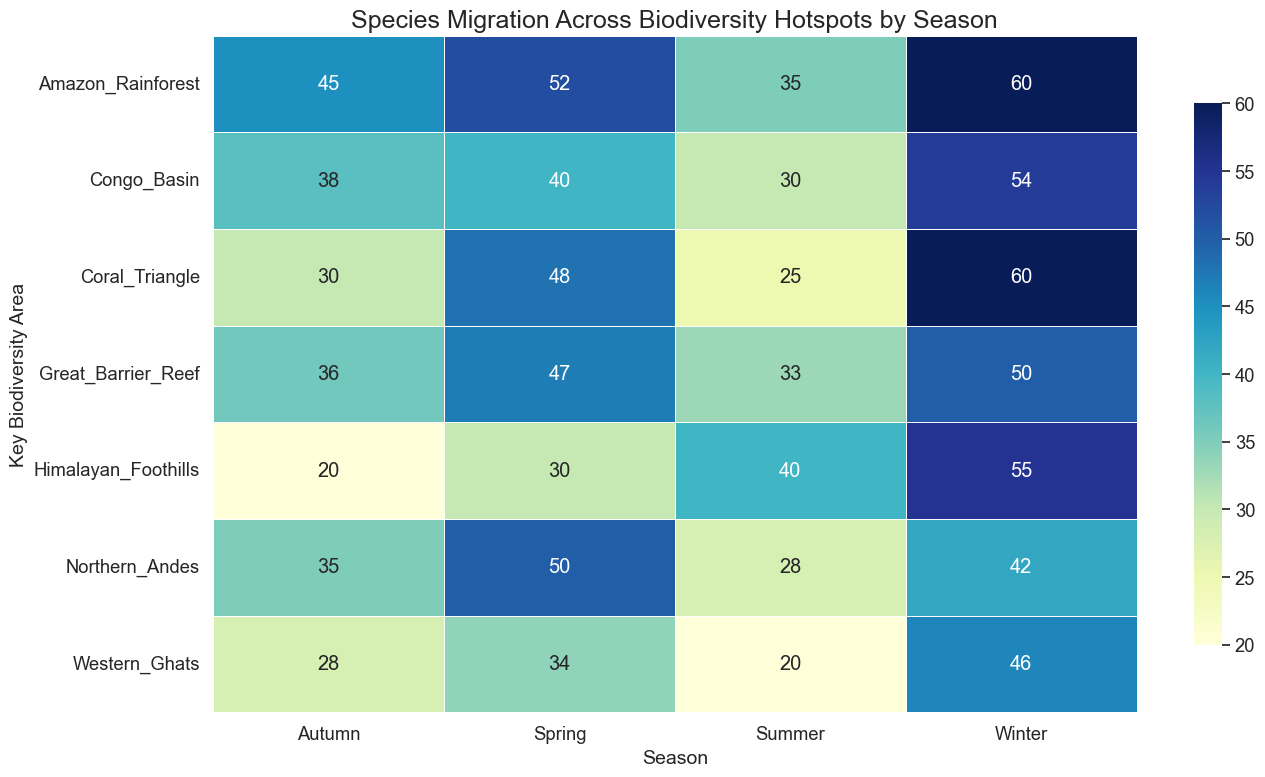What is the average number of species migrated in the Coral Triangle across all seasons? To find the average, sum up the species migrated in each season for Coral Triangle and divide by the number of seasons. The values are 48 in Spring, 25 in Summer, 30 in Autumn, and 60 in Winter. Summing these gives us 48 + 25 + 30 + 60 = 163. There are 4 seasons, so the average is 163 / 4 = 40.75.
Answer: 40.75 Which biodiversity area experiences the highest species migration during winter? To answer this, look at the row labeled "Winter" and find the highest numerical value. Winter values are Amazon Rainforest (60), Congo Basin (54), Coral Triangle (60), Himalayan Foothills (55), Great Barrier Reef (50), Northern Andes (42), and Western Ghats (46). The highest values are in Amazon Rainforest and Coral Triangle, both with 60.
Answer: Amazon Rainforest and Coral Triangle In which season does the Western Ghats have the lowest species migration, and what is that value? Examine the values for the Western Ghats across all seasons. Spring (34), Summer (20), Autumn (28), Winter (46). The lowest value is in Summer with a count of 20.
Answer: Summer, 20 How does species migration in Spring compare between the Amazon Rainforest and the Great Barrier Reef? Look at the species migration values for Spring in both the Amazon Rainforest (52) and the Great Barrier Reef (47). To compare, 52 (Amazon Rainforest) is greater than 47 (Great Barrier Reef).
Answer: Amazon Rainforest has higher migration in Spring What is the difference in species migration between Spring and Autumn in the Northern Andes? Look at the values for Northern Andes in Spring (50) and Autumn (35). To find the difference, compute 50 (Spring) - 35 (Autumn), which equals 15.
Answer: 15 Which season shows the least variation in species migration across all biodiversity areas? To determine the season with the least variation, examine the visual closeness of the values across seasons. Summer values appear closer, with a lower range of variation between maximum and minimum values. Visually the numbers are more 'bunched' together.
Answer: Summer How does species migration in Winter compare between the Himalayan Foothills and Congo Basin? Check the Winter values for the Himalayan Foothills (55) and the Congo Basin (54). To compare, 55 (Himalayan Foothills) is slightly higher than 54 (Congo Basin).
Answer: Himalayan Foothills has higher migration in Winter If you were to sum the species migrations across all seasons for the Great Barrier Reef, what would be the total? Sum up the species migrated in each season for the Great Barrier Reef: Spring (47), Summer (33), Autumn (36), Winter (50). Adding these values gives 47 + 33 + 36 + 50 = 166.
Answer: 166 Which two biodiversity areas have the closest species migration numbers in Winter? Compare the values for Winter across all biodiversity areas: Amazon Rainforest (60), Congo Basin (54), Coral Triangle (60), Himalayan Foothills (55), Great Barrier Reef (50), Northern Andes (42), and Western Ghats (46). The Congo Basin (54) and Himalayan Foothills (55) are closest with only a difference of 1.
Answer: Congo Basin and Himalayan Foothills 